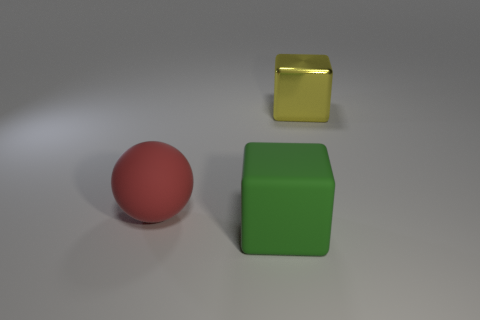What is the material of the green thing?
Ensure brevity in your answer.  Rubber. Is the number of big gray rubber things greater than the number of big red matte spheres?
Your response must be concise. No. Is the red matte thing the same shape as the big metallic thing?
Make the answer very short. No. Is there any other thing that has the same shape as the large green matte thing?
Keep it short and to the point. Yes. Does the large rubber thing that is on the left side of the large green block have the same color as the big cube that is in front of the large red rubber sphere?
Ensure brevity in your answer.  No. Is the number of big metallic things behind the metallic thing less than the number of green rubber cubes behind the green cube?
Make the answer very short. No. There is a big object that is behind the large rubber sphere; what shape is it?
Provide a short and direct response. Cube. What number of other things are there of the same material as the yellow object
Offer a very short reply. 0. There is a large yellow metallic object; is it the same shape as the big rubber object that is left of the green rubber object?
Make the answer very short. No. What is the shape of the object that is the same material as the ball?
Your response must be concise. Cube. 